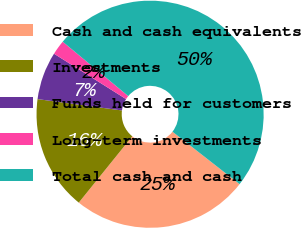Convert chart. <chart><loc_0><loc_0><loc_500><loc_500><pie_chart><fcel>Cash and cash equivalents<fcel>Investments<fcel>Funds held for customers<fcel>Long-term investments<fcel>Total cash and cash<nl><fcel>25.25%<fcel>16.32%<fcel>6.82%<fcel>2.08%<fcel>49.53%<nl></chart> 